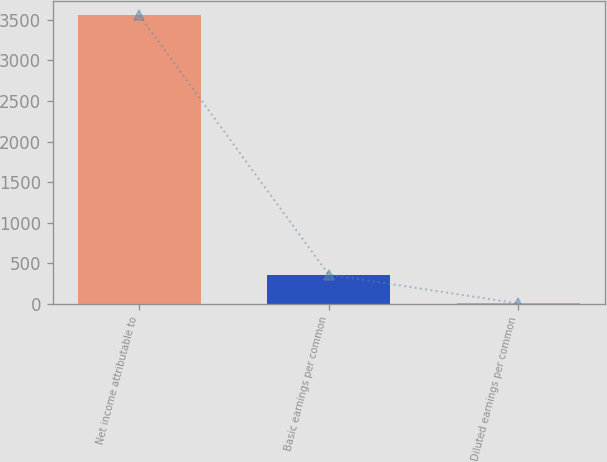Convert chart to OTSL. <chart><loc_0><loc_0><loc_500><loc_500><bar_chart><fcel>Net income attributable to<fcel>Basic earnings per common<fcel>Diluted earnings per common<nl><fcel>3558<fcel>357.83<fcel>2.25<nl></chart> 